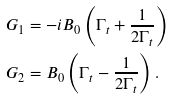Convert formula to latex. <formula><loc_0><loc_0><loc_500><loc_500>G _ { 1 } & = - i B _ { 0 } \left ( \Gamma _ { t } + \frac { 1 } { 2 \Gamma _ { t } } \right ) \\ G _ { 2 } & = B _ { 0 } \left ( \Gamma _ { t } - \frac { 1 } { 2 \Gamma _ { t } } \right ) .</formula> 